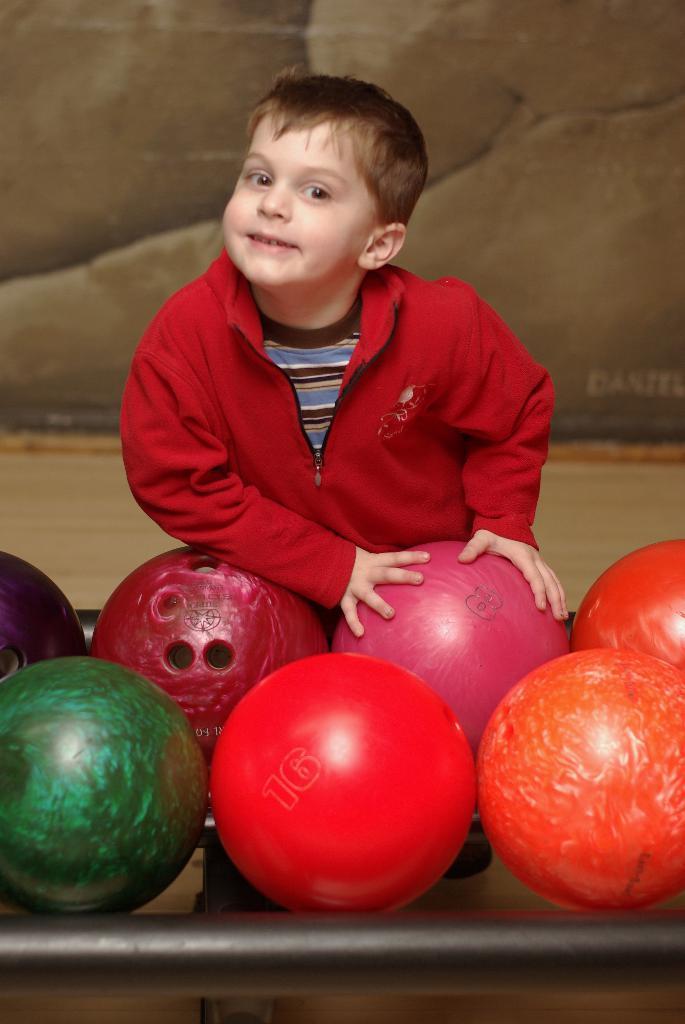Please provide a concise description of this image. In the center of the image we can see a boy standing and smiling, before him there are bowling balls placed on the table. 